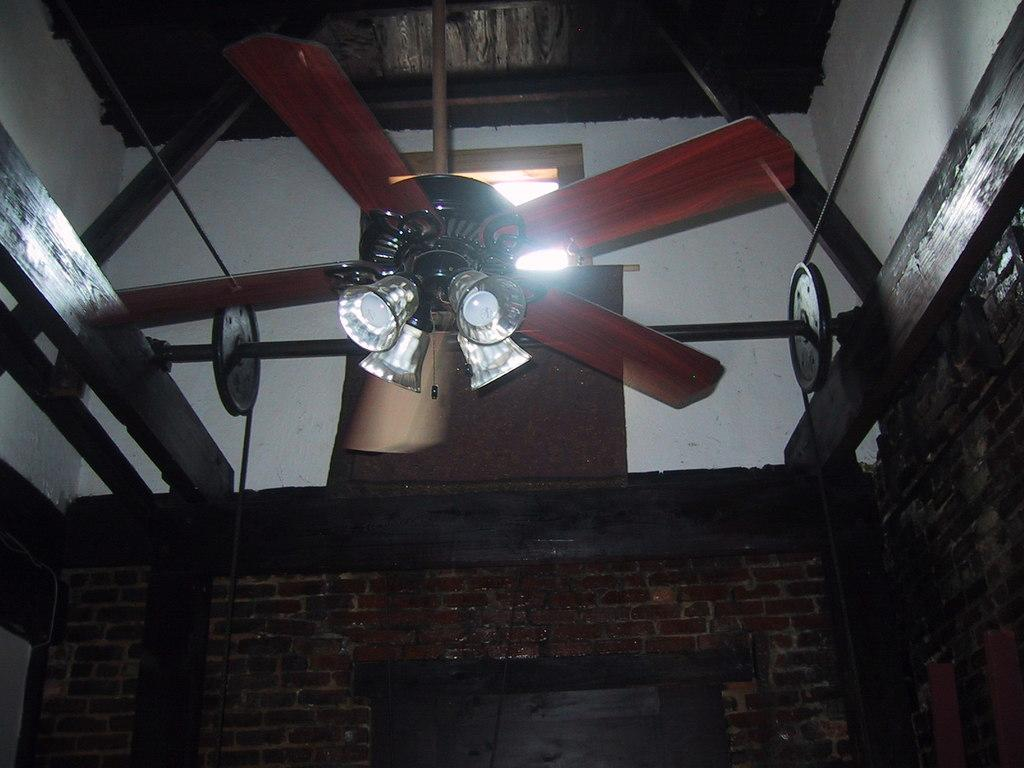What type of device is visible in the image? There is a fan in the image. What can be seen attached to the fan? There are bulbs attached to the fan. What is the background of the image made of? There is a wall in the image. Is there any source of natural light in the image? Yes, there is a window in the image. What type of architectural feature can be seen in the image? There are wooden pillars in the image. What type of whip is being used to control the bulbs in the image? There is no whip present in the image, and the bulbs are not being controlled by any whip. What color is the silver war paint on the wooden pillars in the image? There is no war paint or silver color present on the wooden pillars in the image. 